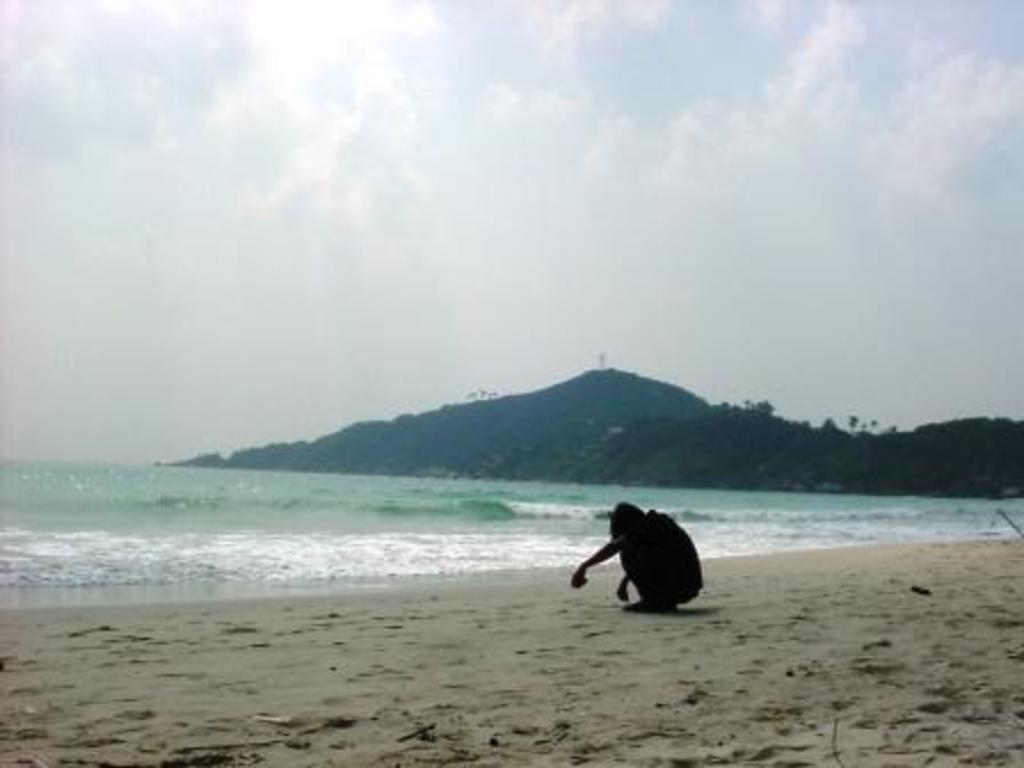Could you give a brief overview of what you see in this image? In this image I see a person and I see the sand and I see the water. In the background I see the mountains and I see the sky. 